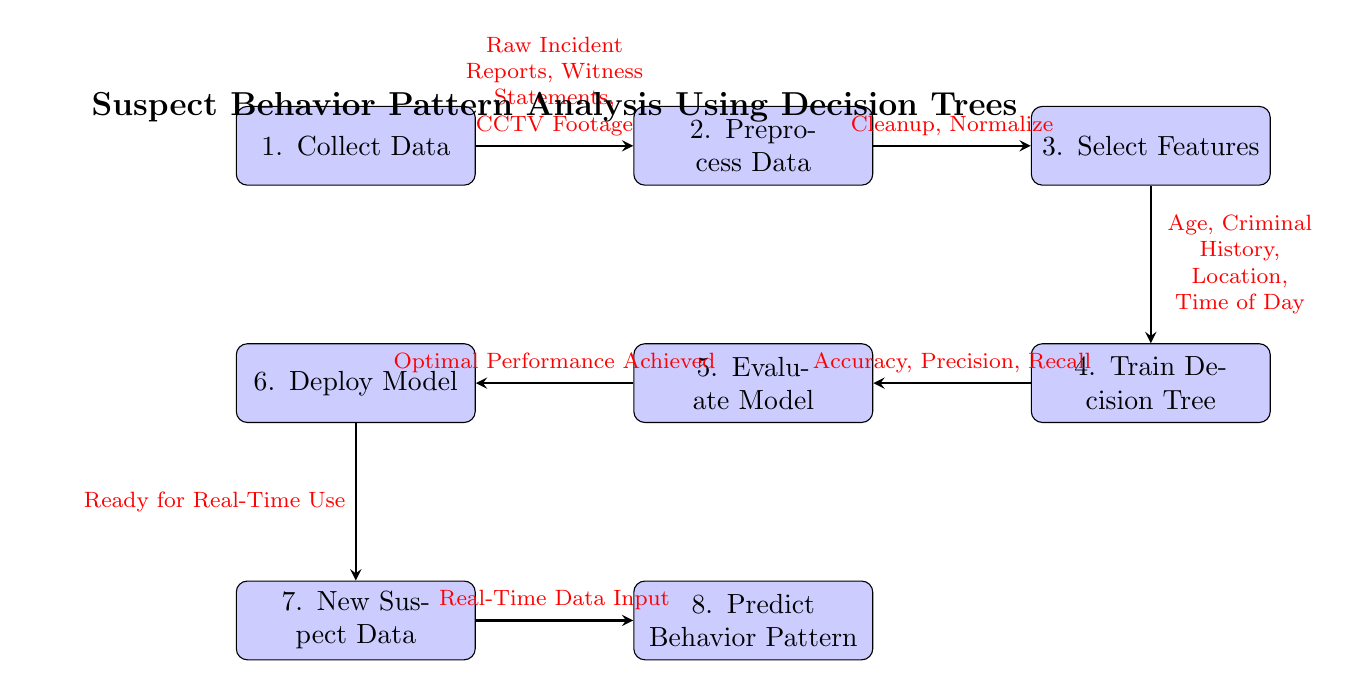What is the first step in the process? The first step is located at the top of the diagram, represented by the node labeled "Collect Data." This indicates that the process begins with gathering the necessary data.
Answer: Collect Data How many main processes are depicted in the diagram? Each process in the diagram is represented by a distinct node, and by counting them, we find that there are eight main processes outlined in the diagram.
Answer: Eight What type of data is used in the "Collect Data" step? The "Collect Data" step includes details about the specific types of data being gathered, as indicated by the label, which mentions "Raw Incident Reports," "Witness Statements," and "CCTV Footage."
Answer: Raw Incident Reports, Witness Statements, CCTV Footage What is evaluated in the "Evaluate Model" step? In this step, the model's performance metrics are assessed, which typically includes checks for accuracy, precision, and recall, as stated in the connections leading to this node.
Answer: Accuracy, Precision, Recall Which process follows after "Deploy Model"? Following the "Deploy Model" process, the next step indicated in the diagram flows to "New Suspect Data," showing that once the model is deployed, it is ready to handle new real-time input.
Answer: New Suspect Data What features are selected before training the decision tree? The features highlighted before training include "Age," "Criminal History," "Location," and "Time of Day," listed directly in the node preceding the training step.
Answer: Age, Criminal History, Location, Time of Day What condition must be met before the model can be deployed? According to the diagram, the condition for deployment is that "Optimal Performance Achieved" must occur during the evaluation of the model, indicating that the model is ready for use.
Answer: Optimal Performance Achieved What kind of data is required for prediction in the last process? The final process in the diagram specifies that "Real-Time Data Input" is necessary for predicting behavior patterns, indicating the type of data required to utilize the deployed model.
Answer: Real-Time Data Input 